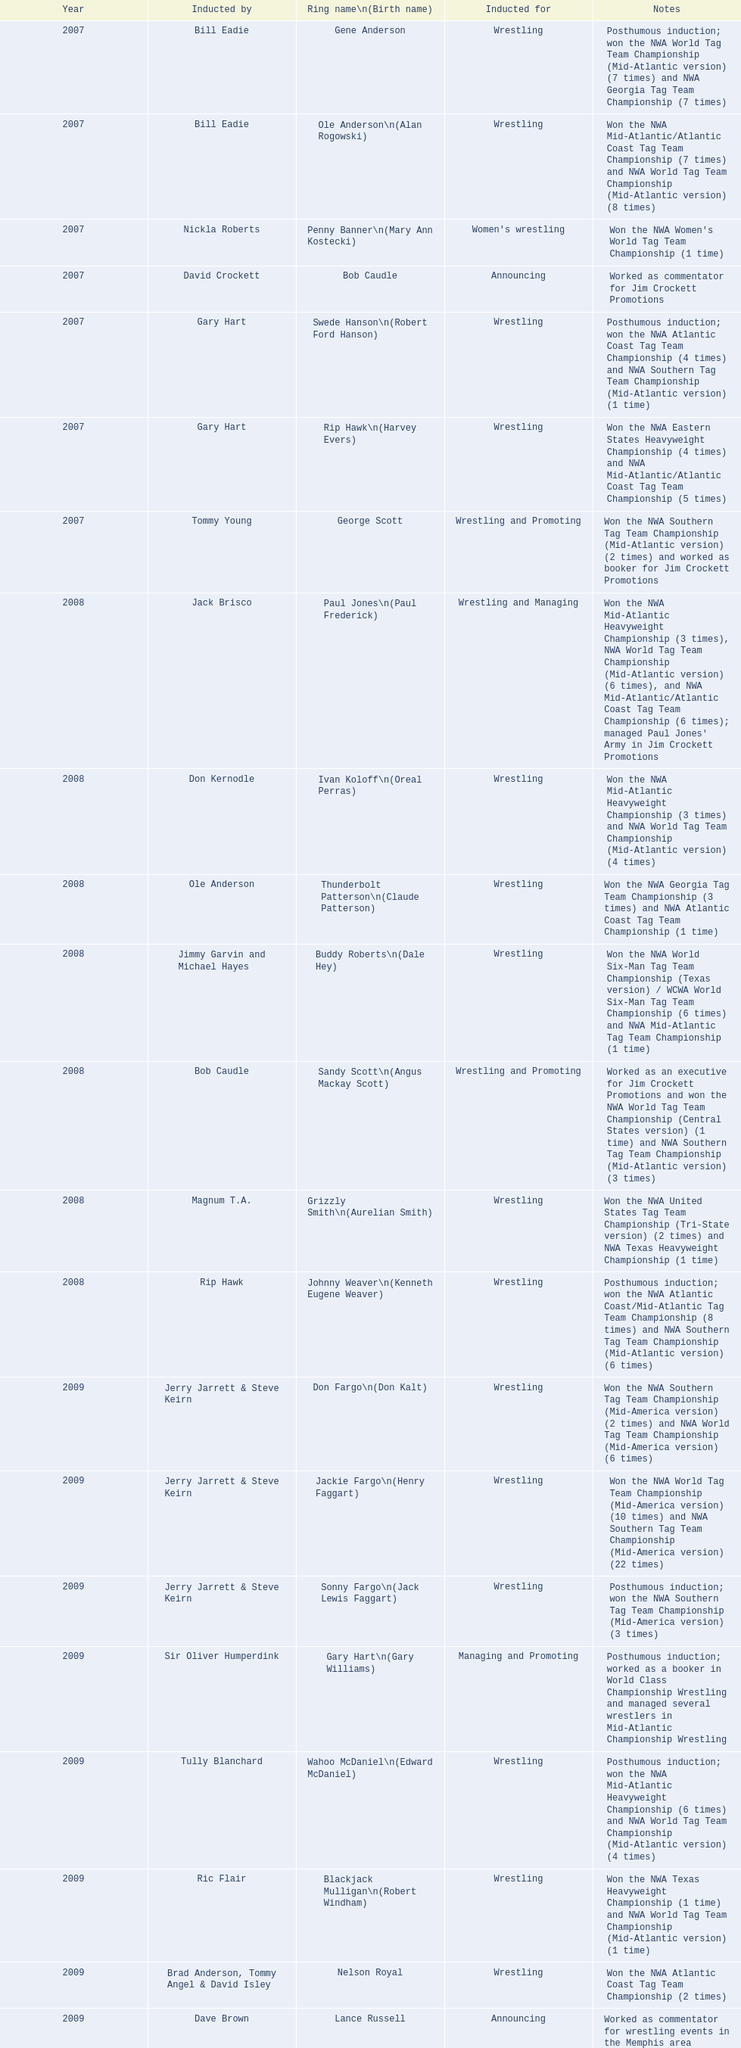What were all the wrestler's ring names? Gene Anderson, Ole Anderson\n(Alan Rogowski), Penny Banner\n(Mary Ann Kostecki), Bob Caudle, Swede Hanson\n(Robert Ford Hanson), Rip Hawk\n(Harvey Evers), George Scott, Paul Jones\n(Paul Frederick), Ivan Koloff\n(Oreal Perras), Thunderbolt Patterson\n(Claude Patterson), Buddy Roberts\n(Dale Hey), Sandy Scott\n(Angus Mackay Scott), Grizzly Smith\n(Aurelian Smith), Johnny Weaver\n(Kenneth Eugene Weaver), Don Fargo\n(Don Kalt), Jackie Fargo\n(Henry Faggart), Sonny Fargo\n(Jack Lewis Faggart), Gary Hart\n(Gary Williams), Wahoo McDaniel\n(Edward McDaniel), Blackjack Mulligan\n(Robert Windham), Nelson Royal, Lance Russell. Besides bob caudle, who was an announcer? Lance Russell. 